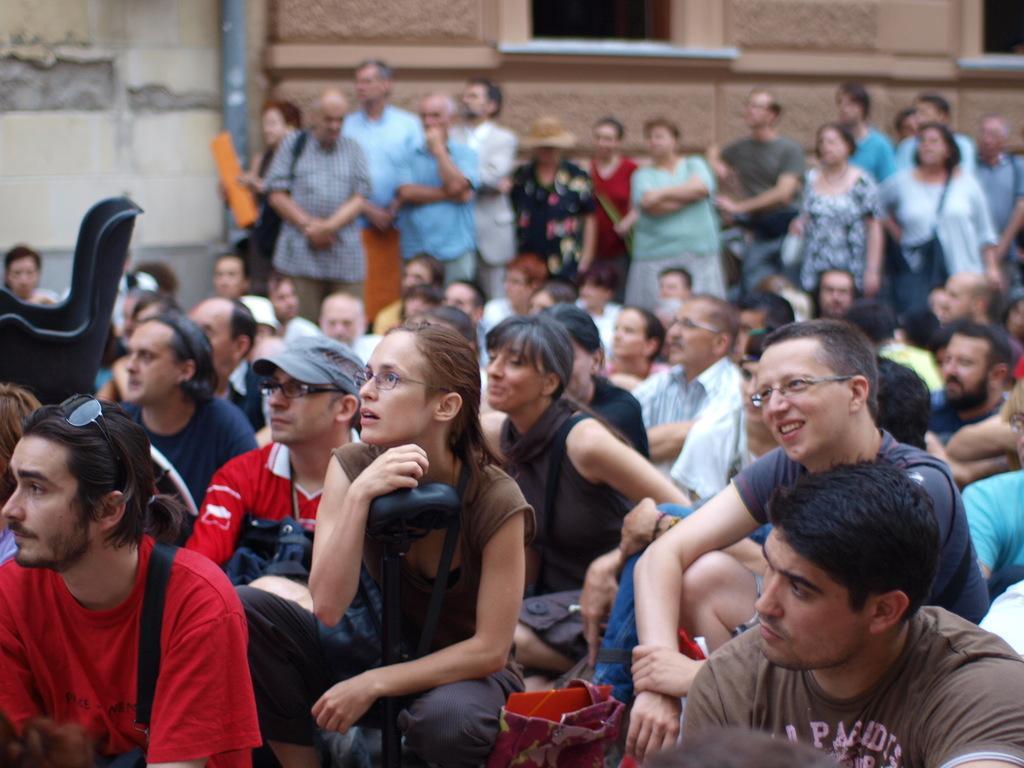How would you summarize this image in a sentence or two? In the center of the image we can see people sitting and some of them are standing. In the background there are buildings. 